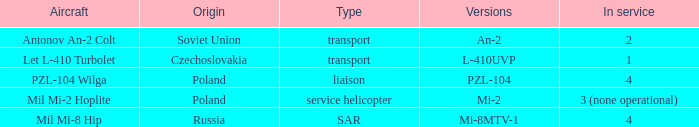Tell me the service for versions l-410uvp 1.0. 